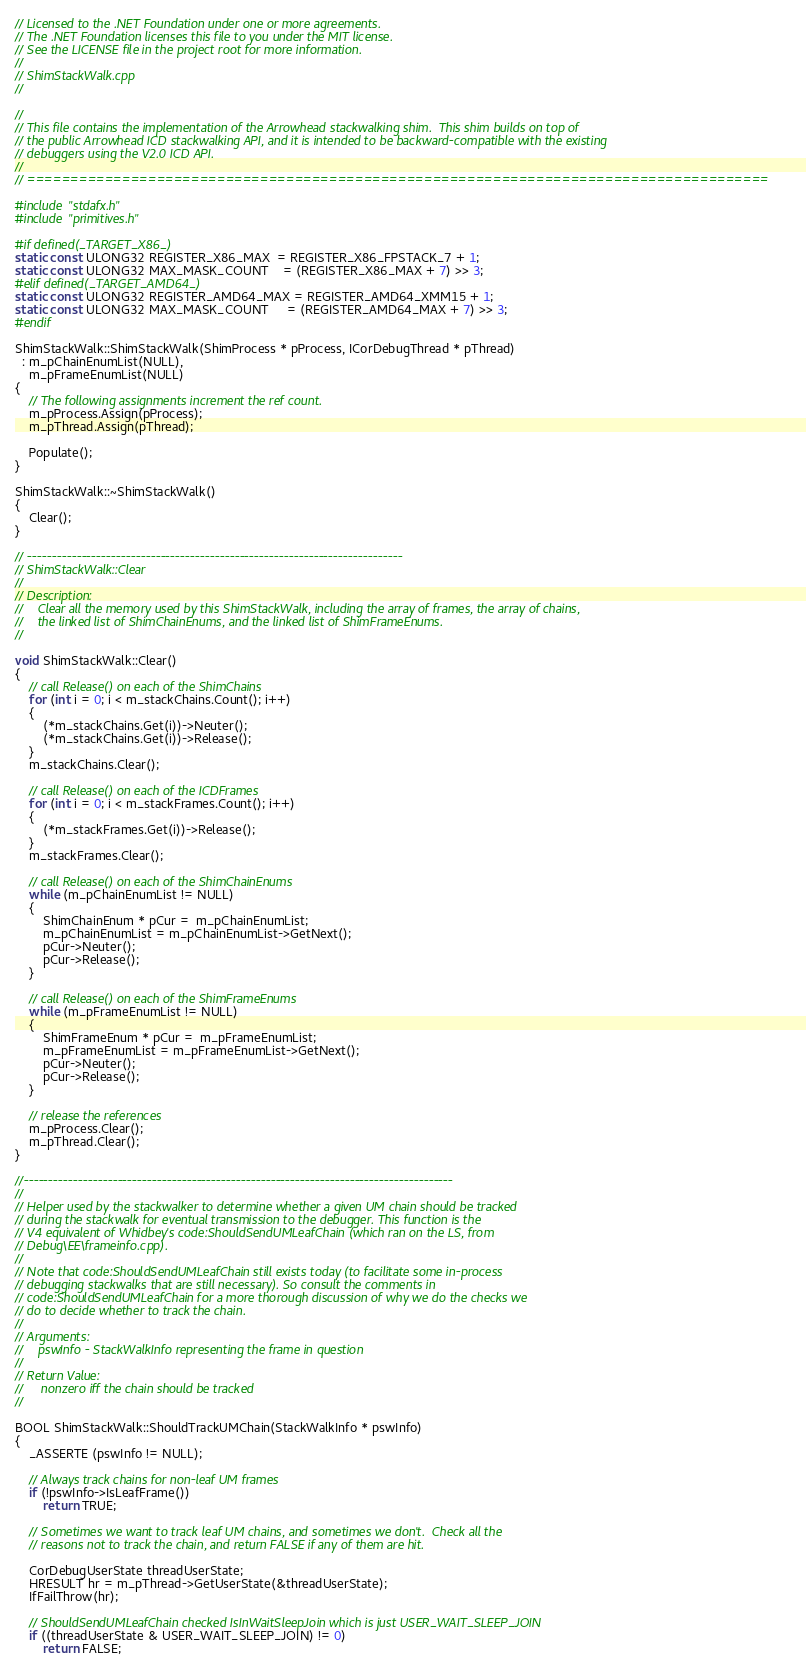<code> <loc_0><loc_0><loc_500><loc_500><_C++_>// Licensed to the .NET Foundation under one or more agreements.
// The .NET Foundation licenses this file to you under the MIT license.
// See the LICENSE file in the project root for more information.
//
// ShimStackWalk.cpp
//

//
// This file contains the implementation of the Arrowhead stackwalking shim.  This shim builds on top of
// the public Arrowhead ICD stackwalking API, and it is intended to be backward-compatible with the existing
// debuggers using the V2.0 ICD API.
//
// ======================================================================================

#include "stdafx.h"
#include "primitives.h"

#if defined(_TARGET_X86_)
static const ULONG32 REGISTER_X86_MAX  = REGISTER_X86_FPSTACK_7 + 1;
static const ULONG32 MAX_MASK_COUNT    = (REGISTER_X86_MAX + 7) >> 3;
#elif defined(_TARGET_AMD64_)
static const ULONG32 REGISTER_AMD64_MAX = REGISTER_AMD64_XMM15 + 1;
static const ULONG32 MAX_MASK_COUNT     = (REGISTER_AMD64_MAX + 7) >> 3;
#endif

ShimStackWalk::ShimStackWalk(ShimProcess * pProcess, ICorDebugThread * pThread)
  : m_pChainEnumList(NULL),
    m_pFrameEnumList(NULL)
{
    // The following assignments increment the ref count.
    m_pProcess.Assign(pProcess);
    m_pThread.Assign(pThread);

    Populate();
}

ShimStackWalk::~ShimStackWalk()
{
    Clear();
}

// ----------------------------------------------------------------------------
// ShimStackWalk::Clear
//
// Description:
//    Clear all the memory used by this ShimStackWalk, including the array of frames, the array of chains,
//    the linked list of ShimChainEnums, and the linked list of ShimFrameEnums.
//

void ShimStackWalk::Clear()
{
    // call Release() on each of the ShimChains
    for (int i = 0; i < m_stackChains.Count(); i++)
    {
        (*m_stackChains.Get(i))->Neuter();
        (*m_stackChains.Get(i))->Release();
    }
    m_stackChains.Clear();

    // call Release() on each of the ICDFrames
    for (int i = 0; i < m_stackFrames.Count(); i++)
    {
        (*m_stackFrames.Get(i))->Release();
    }
    m_stackFrames.Clear();

    // call Release() on each of the ShimChainEnums
    while (m_pChainEnumList != NULL)
    {
        ShimChainEnum * pCur =  m_pChainEnumList;
        m_pChainEnumList = m_pChainEnumList->GetNext();
        pCur->Neuter();
        pCur->Release();
    }

    // call Release() on each of the ShimFrameEnums
    while (m_pFrameEnumList != NULL)
    {
        ShimFrameEnum * pCur =  m_pFrameEnumList;
        m_pFrameEnumList = m_pFrameEnumList->GetNext();
        pCur->Neuter();
        pCur->Release();
    }

    // release the references
    m_pProcess.Clear();
    m_pThread.Clear();
}

//---------------------------------------------------------------------------------------
//
// Helper used by the stackwalker to determine whether a given UM chain should be tracked
// during the stackwalk for eventual transmission to the debugger. This function is the
// V4 equivalent of Whidbey's code:ShouldSendUMLeafChain (which ran on the LS, from
// Debug\EE\frameinfo.cpp).
//
// Note that code:ShouldSendUMLeafChain still exists today (to facilitate some in-process
// debugging stackwalks that are still necessary). So consult the comments in
// code:ShouldSendUMLeafChain for a more thorough discussion of why we do the checks we
// do to decide whether to track the chain.
//
// Arguments:
//    pswInfo - StackWalkInfo representing the frame in question
//
// Return Value:
//     nonzero iff the chain should be tracked
//

BOOL ShimStackWalk::ShouldTrackUMChain(StackWalkInfo * pswInfo)
{
    _ASSERTE (pswInfo != NULL);

    // Always track chains for non-leaf UM frames
    if (!pswInfo->IsLeafFrame())
        return TRUE;

    // Sometimes we want to track leaf UM chains, and sometimes we don't.  Check all the
    // reasons not to track the chain, and return FALSE if any of them are hit.

    CorDebugUserState threadUserState;
    HRESULT hr = m_pThread->GetUserState(&threadUserState);
    IfFailThrow(hr);

    // ShouldSendUMLeafChain checked IsInWaitSleepJoin which is just USER_WAIT_SLEEP_JOIN
    if ((threadUserState & USER_WAIT_SLEEP_JOIN) != 0)
        return FALSE;
</code> 